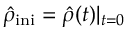Convert formula to latex. <formula><loc_0><loc_0><loc_500><loc_500>{ \hat { \rho } } _ { i n i } = { \hat { \rho } } ( t ) | _ { t = 0 }</formula> 